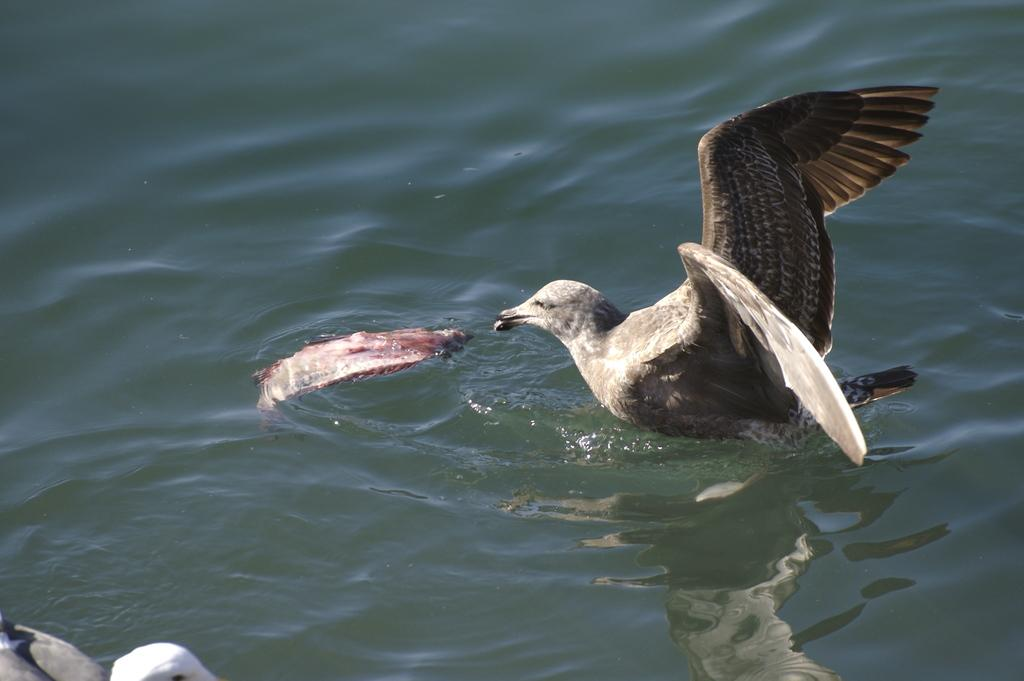What is the primary element in the image? There is water in the image. What type of animal can be seen on the water? There is a bird on the water. Are there any other living creatures visible in the water? Yes, there is a fish in the water. What type of legal advice is the bird seeking from the fish in the image? There is no indication in the image that the bird is seeking legal advice from the fish, as there are no lawyers or parcel present. 